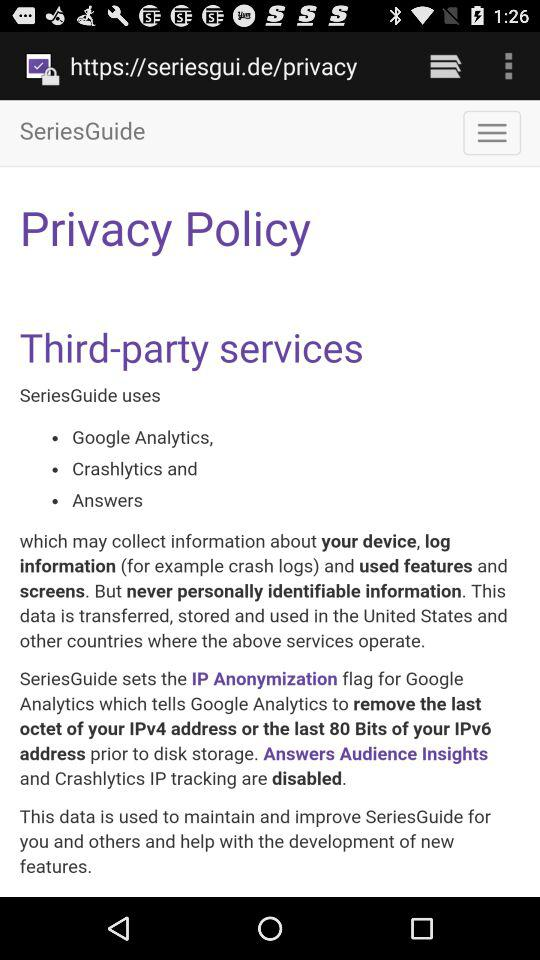How many third-party services does SeriesGuide use?
Answer the question using a single word or phrase. 3 